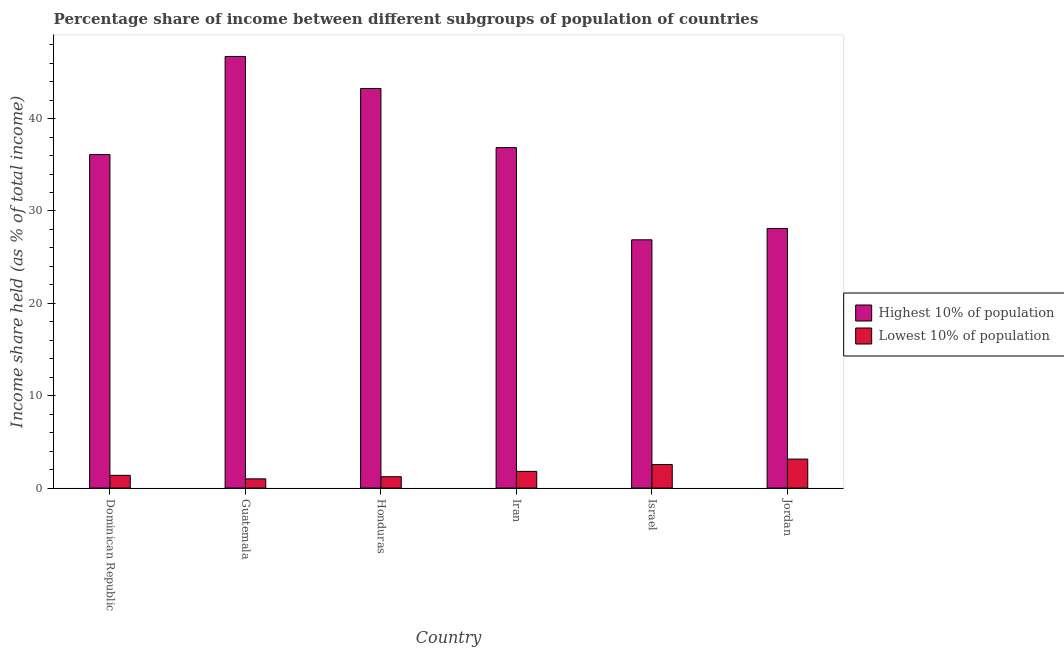How many different coloured bars are there?
Keep it short and to the point. 2. Are the number of bars on each tick of the X-axis equal?
Ensure brevity in your answer.  Yes. How many bars are there on the 3rd tick from the left?
Your answer should be very brief. 2. In how many cases, is the number of bars for a given country not equal to the number of legend labels?
Ensure brevity in your answer.  0. What is the income share held by lowest 10% of the population in Honduras?
Your answer should be very brief. 1.23. Across all countries, what is the maximum income share held by highest 10% of the population?
Make the answer very short. 46.73. Across all countries, what is the minimum income share held by highest 10% of the population?
Provide a short and direct response. 26.88. In which country was the income share held by lowest 10% of the population maximum?
Offer a terse response. Jordan. In which country was the income share held by lowest 10% of the population minimum?
Your answer should be very brief. Guatemala. What is the total income share held by highest 10% of the population in the graph?
Ensure brevity in your answer.  217.95. What is the difference between the income share held by lowest 10% of the population in Dominican Republic and that in Iran?
Ensure brevity in your answer.  -0.43. What is the difference between the income share held by highest 10% of the population in Honduras and the income share held by lowest 10% of the population in Jordan?
Your answer should be very brief. 40.12. What is the average income share held by lowest 10% of the population per country?
Make the answer very short. 1.85. What is the difference between the income share held by highest 10% of the population and income share held by lowest 10% of the population in Israel?
Make the answer very short. 24.33. What is the ratio of the income share held by lowest 10% of the population in Guatemala to that in Honduras?
Offer a terse response. 0.81. What is the difference between the highest and the second highest income share held by highest 10% of the population?
Provide a succinct answer. 3.47. What is the difference between the highest and the lowest income share held by lowest 10% of the population?
Offer a terse response. 2.14. What does the 2nd bar from the left in Dominican Republic represents?
Provide a short and direct response. Lowest 10% of population. What does the 2nd bar from the right in Jordan represents?
Provide a short and direct response. Highest 10% of population. Are all the bars in the graph horizontal?
Your answer should be very brief. No. What is the difference between two consecutive major ticks on the Y-axis?
Your answer should be compact. 10. Are the values on the major ticks of Y-axis written in scientific E-notation?
Make the answer very short. No. How are the legend labels stacked?
Offer a terse response. Vertical. What is the title of the graph?
Give a very brief answer. Percentage share of income between different subgroups of population of countries. Does "From World Bank" appear as one of the legend labels in the graph?
Make the answer very short. No. What is the label or title of the X-axis?
Ensure brevity in your answer.  Country. What is the label or title of the Y-axis?
Your answer should be compact. Income share held (as % of total income). What is the Income share held (as % of total income) of Highest 10% of population in Dominican Republic?
Your answer should be compact. 36.11. What is the Income share held (as % of total income) in Lowest 10% of population in Dominican Republic?
Your answer should be compact. 1.38. What is the Income share held (as % of total income) of Highest 10% of population in Guatemala?
Your response must be concise. 46.73. What is the Income share held (as % of total income) of Lowest 10% of population in Guatemala?
Provide a succinct answer. 1. What is the Income share held (as % of total income) in Highest 10% of population in Honduras?
Keep it short and to the point. 43.26. What is the Income share held (as % of total income) of Lowest 10% of population in Honduras?
Give a very brief answer. 1.23. What is the Income share held (as % of total income) in Highest 10% of population in Iran?
Make the answer very short. 36.86. What is the Income share held (as % of total income) in Lowest 10% of population in Iran?
Provide a short and direct response. 1.81. What is the Income share held (as % of total income) of Highest 10% of population in Israel?
Make the answer very short. 26.88. What is the Income share held (as % of total income) of Lowest 10% of population in Israel?
Provide a short and direct response. 2.55. What is the Income share held (as % of total income) of Highest 10% of population in Jordan?
Offer a very short reply. 28.11. What is the Income share held (as % of total income) of Lowest 10% of population in Jordan?
Keep it short and to the point. 3.14. Across all countries, what is the maximum Income share held (as % of total income) of Highest 10% of population?
Your answer should be compact. 46.73. Across all countries, what is the maximum Income share held (as % of total income) in Lowest 10% of population?
Offer a terse response. 3.14. Across all countries, what is the minimum Income share held (as % of total income) in Highest 10% of population?
Offer a very short reply. 26.88. Across all countries, what is the minimum Income share held (as % of total income) in Lowest 10% of population?
Your response must be concise. 1. What is the total Income share held (as % of total income) of Highest 10% of population in the graph?
Your answer should be compact. 217.95. What is the total Income share held (as % of total income) in Lowest 10% of population in the graph?
Offer a terse response. 11.11. What is the difference between the Income share held (as % of total income) in Highest 10% of population in Dominican Republic and that in Guatemala?
Your answer should be very brief. -10.62. What is the difference between the Income share held (as % of total income) of Lowest 10% of population in Dominican Republic and that in Guatemala?
Keep it short and to the point. 0.38. What is the difference between the Income share held (as % of total income) of Highest 10% of population in Dominican Republic and that in Honduras?
Provide a short and direct response. -7.15. What is the difference between the Income share held (as % of total income) of Highest 10% of population in Dominican Republic and that in Iran?
Your answer should be compact. -0.75. What is the difference between the Income share held (as % of total income) in Lowest 10% of population in Dominican Republic and that in Iran?
Give a very brief answer. -0.43. What is the difference between the Income share held (as % of total income) in Highest 10% of population in Dominican Republic and that in Israel?
Offer a terse response. 9.23. What is the difference between the Income share held (as % of total income) of Lowest 10% of population in Dominican Republic and that in Israel?
Provide a short and direct response. -1.17. What is the difference between the Income share held (as % of total income) of Lowest 10% of population in Dominican Republic and that in Jordan?
Ensure brevity in your answer.  -1.76. What is the difference between the Income share held (as % of total income) in Highest 10% of population in Guatemala and that in Honduras?
Offer a terse response. 3.47. What is the difference between the Income share held (as % of total income) in Lowest 10% of population in Guatemala and that in Honduras?
Provide a succinct answer. -0.23. What is the difference between the Income share held (as % of total income) of Highest 10% of population in Guatemala and that in Iran?
Your response must be concise. 9.87. What is the difference between the Income share held (as % of total income) of Lowest 10% of population in Guatemala and that in Iran?
Provide a succinct answer. -0.81. What is the difference between the Income share held (as % of total income) of Highest 10% of population in Guatemala and that in Israel?
Keep it short and to the point. 19.85. What is the difference between the Income share held (as % of total income) in Lowest 10% of population in Guatemala and that in Israel?
Offer a terse response. -1.55. What is the difference between the Income share held (as % of total income) of Highest 10% of population in Guatemala and that in Jordan?
Offer a terse response. 18.62. What is the difference between the Income share held (as % of total income) in Lowest 10% of population in Guatemala and that in Jordan?
Provide a succinct answer. -2.14. What is the difference between the Income share held (as % of total income) in Lowest 10% of population in Honduras and that in Iran?
Ensure brevity in your answer.  -0.58. What is the difference between the Income share held (as % of total income) of Highest 10% of population in Honduras and that in Israel?
Offer a terse response. 16.38. What is the difference between the Income share held (as % of total income) of Lowest 10% of population in Honduras and that in Israel?
Provide a succinct answer. -1.32. What is the difference between the Income share held (as % of total income) in Highest 10% of population in Honduras and that in Jordan?
Offer a very short reply. 15.15. What is the difference between the Income share held (as % of total income) in Lowest 10% of population in Honduras and that in Jordan?
Offer a terse response. -1.91. What is the difference between the Income share held (as % of total income) of Highest 10% of population in Iran and that in Israel?
Keep it short and to the point. 9.98. What is the difference between the Income share held (as % of total income) in Lowest 10% of population in Iran and that in Israel?
Your response must be concise. -0.74. What is the difference between the Income share held (as % of total income) in Highest 10% of population in Iran and that in Jordan?
Your response must be concise. 8.75. What is the difference between the Income share held (as % of total income) in Lowest 10% of population in Iran and that in Jordan?
Your answer should be very brief. -1.33. What is the difference between the Income share held (as % of total income) in Highest 10% of population in Israel and that in Jordan?
Your response must be concise. -1.23. What is the difference between the Income share held (as % of total income) of Lowest 10% of population in Israel and that in Jordan?
Your answer should be compact. -0.59. What is the difference between the Income share held (as % of total income) of Highest 10% of population in Dominican Republic and the Income share held (as % of total income) of Lowest 10% of population in Guatemala?
Provide a succinct answer. 35.11. What is the difference between the Income share held (as % of total income) in Highest 10% of population in Dominican Republic and the Income share held (as % of total income) in Lowest 10% of population in Honduras?
Ensure brevity in your answer.  34.88. What is the difference between the Income share held (as % of total income) of Highest 10% of population in Dominican Republic and the Income share held (as % of total income) of Lowest 10% of population in Iran?
Ensure brevity in your answer.  34.3. What is the difference between the Income share held (as % of total income) of Highest 10% of population in Dominican Republic and the Income share held (as % of total income) of Lowest 10% of population in Israel?
Make the answer very short. 33.56. What is the difference between the Income share held (as % of total income) in Highest 10% of population in Dominican Republic and the Income share held (as % of total income) in Lowest 10% of population in Jordan?
Offer a terse response. 32.97. What is the difference between the Income share held (as % of total income) in Highest 10% of population in Guatemala and the Income share held (as % of total income) in Lowest 10% of population in Honduras?
Make the answer very short. 45.5. What is the difference between the Income share held (as % of total income) in Highest 10% of population in Guatemala and the Income share held (as % of total income) in Lowest 10% of population in Iran?
Make the answer very short. 44.92. What is the difference between the Income share held (as % of total income) in Highest 10% of population in Guatemala and the Income share held (as % of total income) in Lowest 10% of population in Israel?
Give a very brief answer. 44.18. What is the difference between the Income share held (as % of total income) of Highest 10% of population in Guatemala and the Income share held (as % of total income) of Lowest 10% of population in Jordan?
Keep it short and to the point. 43.59. What is the difference between the Income share held (as % of total income) in Highest 10% of population in Honduras and the Income share held (as % of total income) in Lowest 10% of population in Iran?
Your answer should be very brief. 41.45. What is the difference between the Income share held (as % of total income) in Highest 10% of population in Honduras and the Income share held (as % of total income) in Lowest 10% of population in Israel?
Make the answer very short. 40.71. What is the difference between the Income share held (as % of total income) in Highest 10% of population in Honduras and the Income share held (as % of total income) in Lowest 10% of population in Jordan?
Offer a very short reply. 40.12. What is the difference between the Income share held (as % of total income) of Highest 10% of population in Iran and the Income share held (as % of total income) of Lowest 10% of population in Israel?
Offer a very short reply. 34.31. What is the difference between the Income share held (as % of total income) in Highest 10% of population in Iran and the Income share held (as % of total income) in Lowest 10% of population in Jordan?
Offer a very short reply. 33.72. What is the difference between the Income share held (as % of total income) in Highest 10% of population in Israel and the Income share held (as % of total income) in Lowest 10% of population in Jordan?
Provide a short and direct response. 23.74. What is the average Income share held (as % of total income) in Highest 10% of population per country?
Keep it short and to the point. 36.33. What is the average Income share held (as % of total income) of Lowest 10% of population per country?
Your answer should be very brief. 1.85. What is the difference between the Income share held (as % of total income) in Highest 10% of population and Income share held (as % of total income) in Lowest 10% of population in Dominican Republic?
Offer a terse response. 34.73. What is the difference between the Income share held (as % of total income) of Highest 10% of population and Income share held (as % of total income) of Lowest 10% of population in Guatemala?
Your answer should be very brief. 45.73. What is the difference between the Income share held (as % of total income) in Highest 10% of population and Income share held (as % of total income) in Lowest 10% of population in Honduras?
Ensure brevity in your answer.  42.03. What is the difference between the Income share held (as % of total income) in Highest 10% of population and Income share held (as % of total income) in Lowest 10% of population in Iran?
Offer a terse response. 35.05. What is the difference between the Income share held (as % of total income) in Highest 10% of population and Income share held (as % of total income) in Lowest 10% of population in Israel?
Provide a succinct answer. 24.33. What is the difference between the Income share held (as % of total income) of Highest 10% of population and Income share held (as % of total income) of Lowest 10% of population in Jordan?
Your answer should be very brief. 24.97. What is the ratio of the Income share held (as % of total income) of Highest 10% of population in Dominican Republic to that in Guatemala?
Your answer should be very brief. 0.77. What is the ratio of the Income share held (as % of total income) in Lowest 10% of population in Dominican Republic to that in Guatemala?
Keep it short and to the point. 1.38. What is the ratio of the Income share held (as % of total income) in Highest 10% of population in Dominican Republic to that in Honduras?
Make the answer very short. 0.83. What is the ratio of the Income share held (as % of total income) of Lowest 10% of population in Dominican Republic to that in Honduras?
Provide a short and direct response. 1.12. What is the ratio of the Income share held (as % of total income) in Highest 10% of population in Dominican Republic to that in Iran?
Your answer should be compact. 0.98. What is the ratio of the Income share held (as % of total income) in Lowest 10% of population in Dominican Republic to that in Iran?
Offer a terse response. 0.76. What is the ratio of the Income share held (as % of total income) in Highest 10% of population in Dominican Republic to that in Israel?
Your answer should be compact. 1.34. What is the ratio of the Income share held (as % of total income) in Lowest 10% of population in Dominican Republic to that in Israel?
Your answer should be compact. 0.54. What is the ratio of the Income share held (as % of total income) in Highest 10% of population in Dominican Republic to that in Jordan?
Ensure brevity in your answer.  1.28. What is the ratio of the Income share held (as % of total income) in Lowest 10% of population in Dominican Republic to that in Jordan?
Ensure brevity in your answer.  0.44. What is the ratio of the Income share held (as % of total income) in Highest 10% of population in Guatemala to that in Honduras?
Offer a terse response. 1.08. What is the ratio of the Income share held (as % of total income) of Lowest 10% of population in Guatemala to that in Honduras?
Your response must be concise. 0.81. What is the ratio of the Income share held (as % of total income) in Highest 10% of population in Guatemala to that in Iran?
Keep it short and to the point. 1.27. What is the ratio of the Income share held (as % of total income) in Lowest 10% of population in Guatemala to that in Iran?
Give a very brief answer. 0.55. What is the ratio of the Income share held (as % of total income) in Highest 10% of population in Guatemala to that in Israel?
Your response must be concise. 1.74. What is the ratio of the Income share held (as % of total income) of Lowest 10% of population in Guatemala to that in Israel?
Your answer should be very brief. 0.39. What is the ratio of the Income share held (as % of total income) of Highest 10% of population in Guatemala to that in Jordan?
Ensure brevity in your answer.  1.66. What is the ratio of the Income share held (as % of total income) in Lowest 10% of population in Guatemala to that in Jordan?
Offer a very short reply. 0.32. What is the ratio of the Income share held (as % of total income) of Highest 10% of population in Honduras to that in Iran?
Your response must be concise. 1.17. What is the ratio of the Income share held (as % of total income) of Lowest 10% of population in Honduras to that in Iran?
Ensure brevity in your answer.  0.68. What is the ratio of the Income share held (as % of total income) in Highest 10% of population in Honduras to that in Israel?
Ensure brevity in your answer.  1.61. What is the ratio of the Income share held (as % of total income) in Lowest 10% of population in Honduras to that in Israel?
Make the answer very short. 0.48. What is the ratio of the Income share held (as % of total income) in Highest 10% of population in Honduras to that in Jordan?
Provide a succinct answer. 1.54. What is the ratio of the Income share held (as % of total income) of Lowest 10% of population in Honduras to that in Jordan?
Ensure brevity in your answer.  0.39. What is the ratio of the Income share held (as % of total income) in Highest 10% of population in Iran to that in Israel?
Keep it short and to the point. 1.37. What is the ratio of the Income share held (as % of total income) in Lowest 10% of population in Iran to that in Israel?
Give a very brief answer. 0.71. What is the ratio of the Income share held (as % of total income) in Highest 10% of population in Iran to that in Jordan?
Give a very brief answer. 1.31. What is the ratio of the Income share held (as % of total income) in Lowest 10% of population in Iran to that in Jordan?
Ensure brevity in your answer.  0.58. What is the ratio of the Income share held (as % of total income) in Highest 10% of population in Israel to that in Jordan?
Give a very brief answer. 0.96. What is the ratio of the Income share held (as % of total income) of Lowest 10% of population in Israel to that in Jordan?
Offer a very short reply. 0.81. What is the difference between the highest and the second highest Income share held (as % of total income) in Highest 10% of population?
Keep it short and to the point. 3.47. What is the difference between the highest and the second highest Income share held (as % of total income) of Lowest 10% of population?
Make the answer very short. 0.59. What is the difference between the highest and the lowest Income share held (as % of total income) in Highest 10% of population?
Your response must be concise. 19.85. What is the difference between the highest and the lowest Income share held (as % of total income) in Lowest 10% of population?
Offer a terse response. 2.14. 